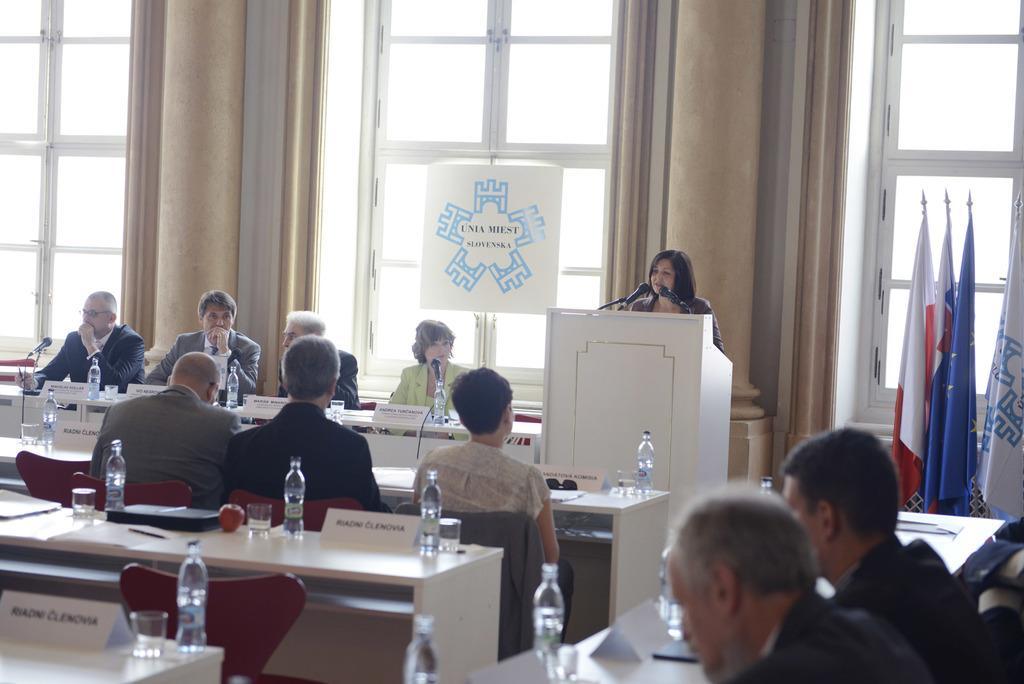Describe this image in one or two sentences. The image is inside the conference hall. In the image there are group of people who are sitting on chair in front of a table, On table we can see a water bottle,glass,apple,laptop,paper,microphone. In middle there is a woman standing in front of a podium, on podium we can see a microphone. On right side there is a window which is closed,curtain which are in cream color,flags. In background there is a hoarding and a wall which is in cream color. 